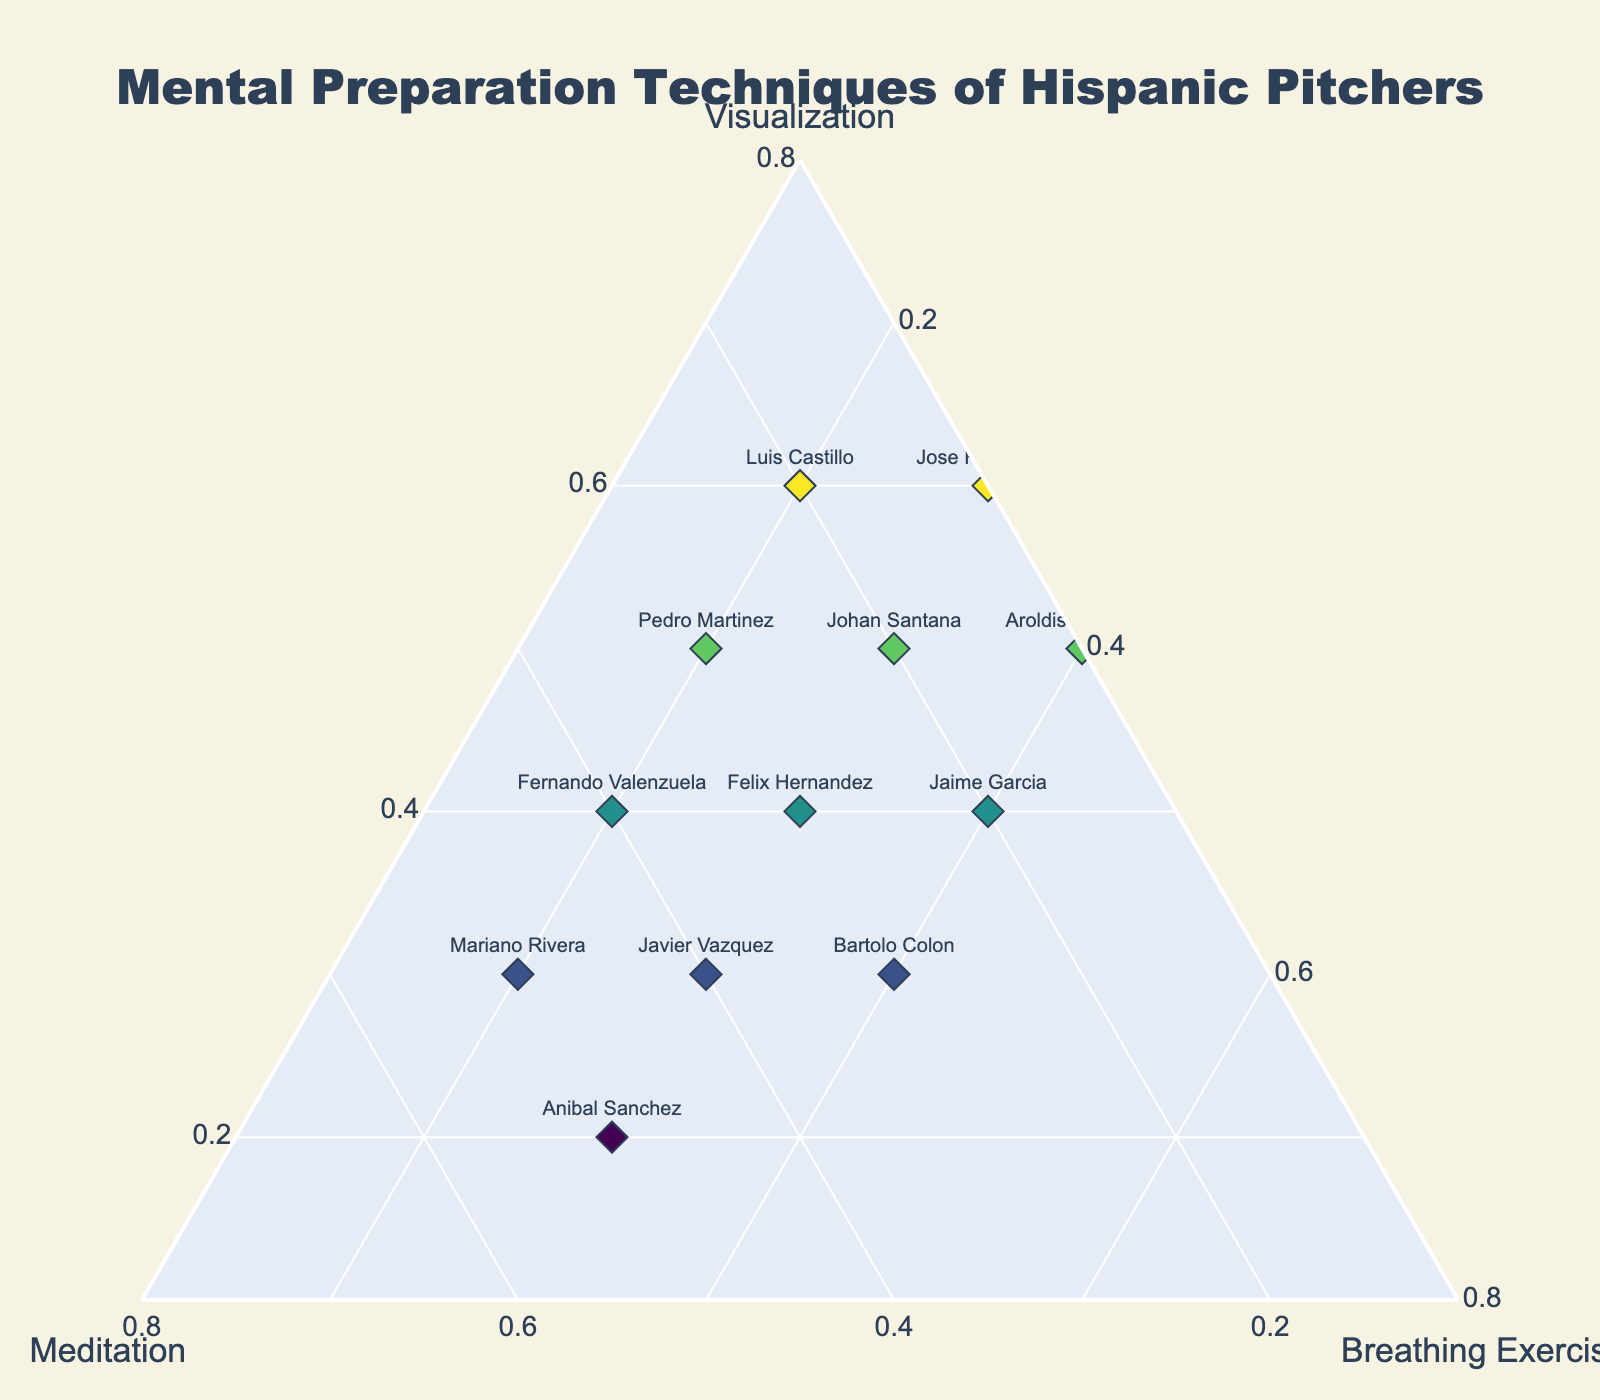What's the title of the figure? The title of the figure is usually located at the top center of the plot. In this case, it reads "Mental Preparation Techniques of Hispanic Pitchers."
Answer: Mental Preparation Techniques of Hispanic Pitchers How many pitchers are displayed on the plot? Count the number of different pitcher names labeled on the ternary plot to determine the total number of data points.
Answer: 12 Which pitcher uses the highest proportion of meditation for mental preparation? Look at the axis labeled "Meditation" and identify the point farthest in that direction. Mariano Rivera, with a normalized proportion of 0.5, uses the highest proportion of meditation.
Answer: Mariano Rivera Which three pitchers have an equal proportion of breathing exercises (0.3) in their preparation techniques? Identify the points along the "Breathing Exercises" axis where the value is 0.3 and cross-reference the names of the pitchers at these positions.
Answer: Johan Santana, Felix Hernandez, Javier Vazquez Which mental preparation technique does Bartolo Colon prefer the least? Examine Bartolo Colon's position on the ternary plot relative to the axes. The lowest proportion for him is along the "Visualization" axis at 0.3.
Answer: Visualization Who uses a combination of 0.5 for both visualization and breathing exercises? Search for the point where both visualization and breathing exercises are around 0.5. Aroldis Chapman matches this combination.
Answer: Aroldis Chapman Compare Luis Castillo and Fernando Valenzuela. Who relies more on visualization for their mental preparation? Look at the normalized visualization values on the plot for Luis Castillo (0.6) and Fernando Valenzuela (0.4). Luis Castillo relies more on visualization.
Answer: Luis Castillo Are there any pitchers that have a balanced approach (equal parts) in their mental preparation techniques? Check if any data points fall approximately at the center of the ternary plot, which would indicate roughly equal proportions of all three techniques.
Answer: No What is the distribution of mental techniques all pitchers use for visualization, from highest to lowest? Rank the pitchers by their normalized visualization values, highest to lowest: Luis Castillo, Jose Fernandez, Pedro Martinez, Aroldis Chapman, Johan Santana, Fernando Valenzuela, Felix Hernandez, Jaime Garcia, Bartolo Colon, Javier Vazquez, Mariano Rivera, Anibal Sanchez.
Answer: Luis Castillo, Jose Fernandez, Pedro Martinez, Aroldis Chapman, Johan Santana, Fernando Valenzuela, Felix Hernandez, Jaime Garcia, Bartolo Colon, Javier Vazquez, Mariano Rivera, Anibal Sanchez What technique does Anibal Sanchez rely on the most and the least for mental preparation? Examine Anibal Sanchez's position relative to the axes. Most is meditation (0.5), and least is visualization (0.2).
Answer: Most: Meditation, Least: Visualization 